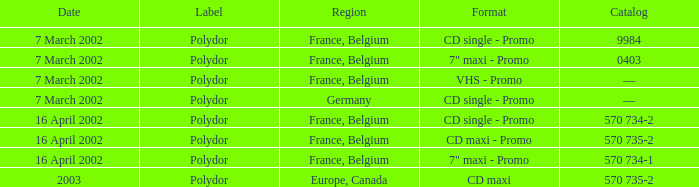Which region had a release format of CD Maxi? Europe, Canada. 